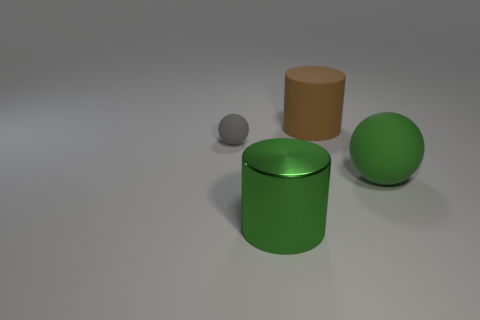Add 2 brown rubber objects. How many objects exist? 6 Subtract all green metallic cylinders. Subtract all matte things. How many objects are left? 0 Add 3 big metal objects. How many big metal objects are left? 4 Add 1 big brown rubber cylinders. How many big brown rubber cylinders exist? 2 Subtract 0 brown balls. How many objects are left? 4 